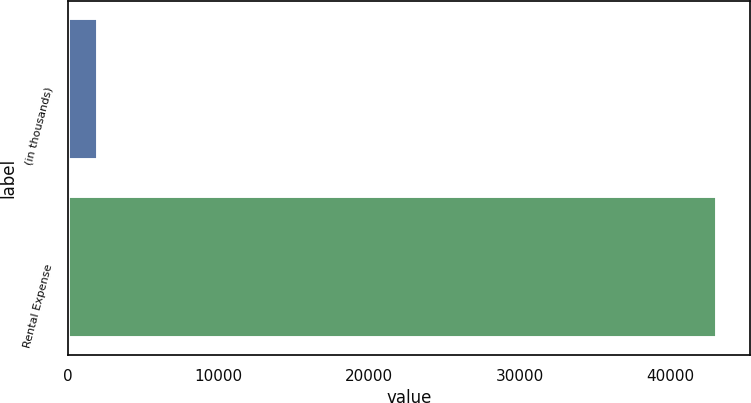Convert chart. <chart><loc_0><loc_0><loc_500><loc_500><bar_chart><fcel>(in thousands)<fcel>Rental Expense<nl><fcel>2010<fcel>43135<nl></chart> 